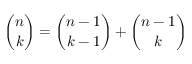Convert formula to latex. <formula><loc_0><loc_0><loc_500><loc_500>{ \binom { n } { k } } = { \binom { n - 1 } { k - 1 } } + { \binom { n - 1 } { k } }</formula> 